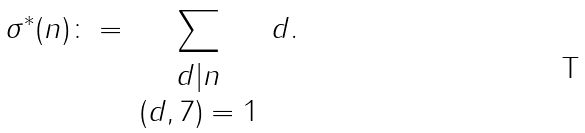<formula> <loc_0><loc_0><loc_500><loc_500>\sigma ^ { * } ( n ) \colon = \sum _ { \begin{array} { c c } d | n \\ ( d , 7 ) = 1 \end{array} } d .</formula> 